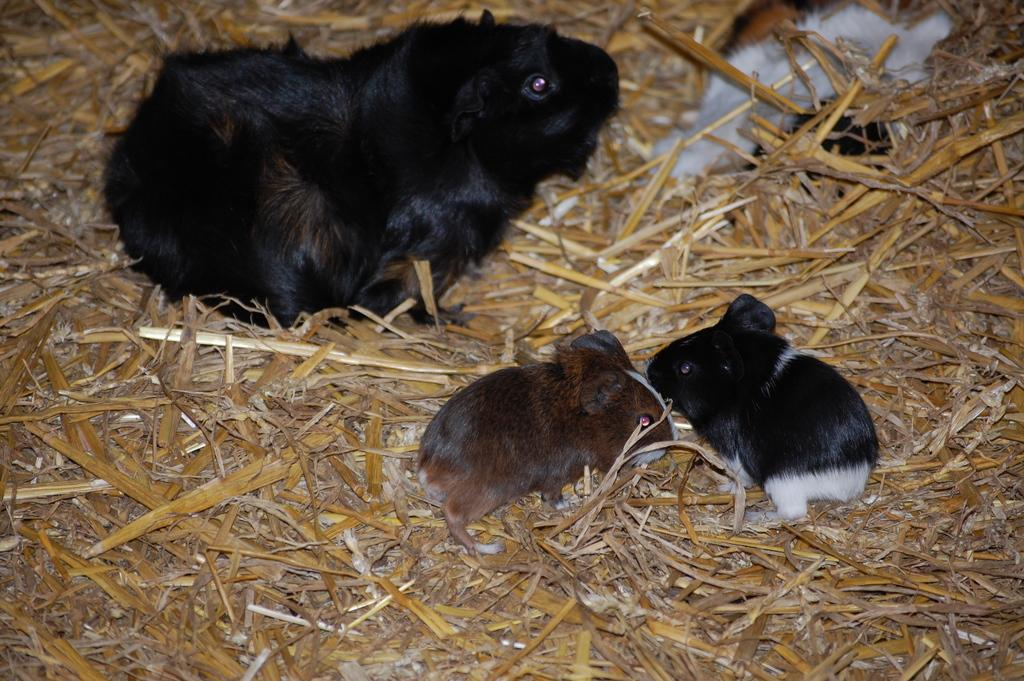What animals can be seen on the ground in the image? There are rats on the ground in the image. What type of vegetation is present on the ground in the image? There is dried grass on the ground in the image. What type of boot can be seen in the image? There is no boot present in the image. What kind of noise can be heard coming from the rats in the image? There is no sound or noise depicted in the image, so it's not possible to determine what, if any, noise might be heard. 